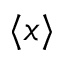Convert formula to latex. <formula><loc_0><loc_0><loc_500><loc_500>\langle x \rangle</formula> 